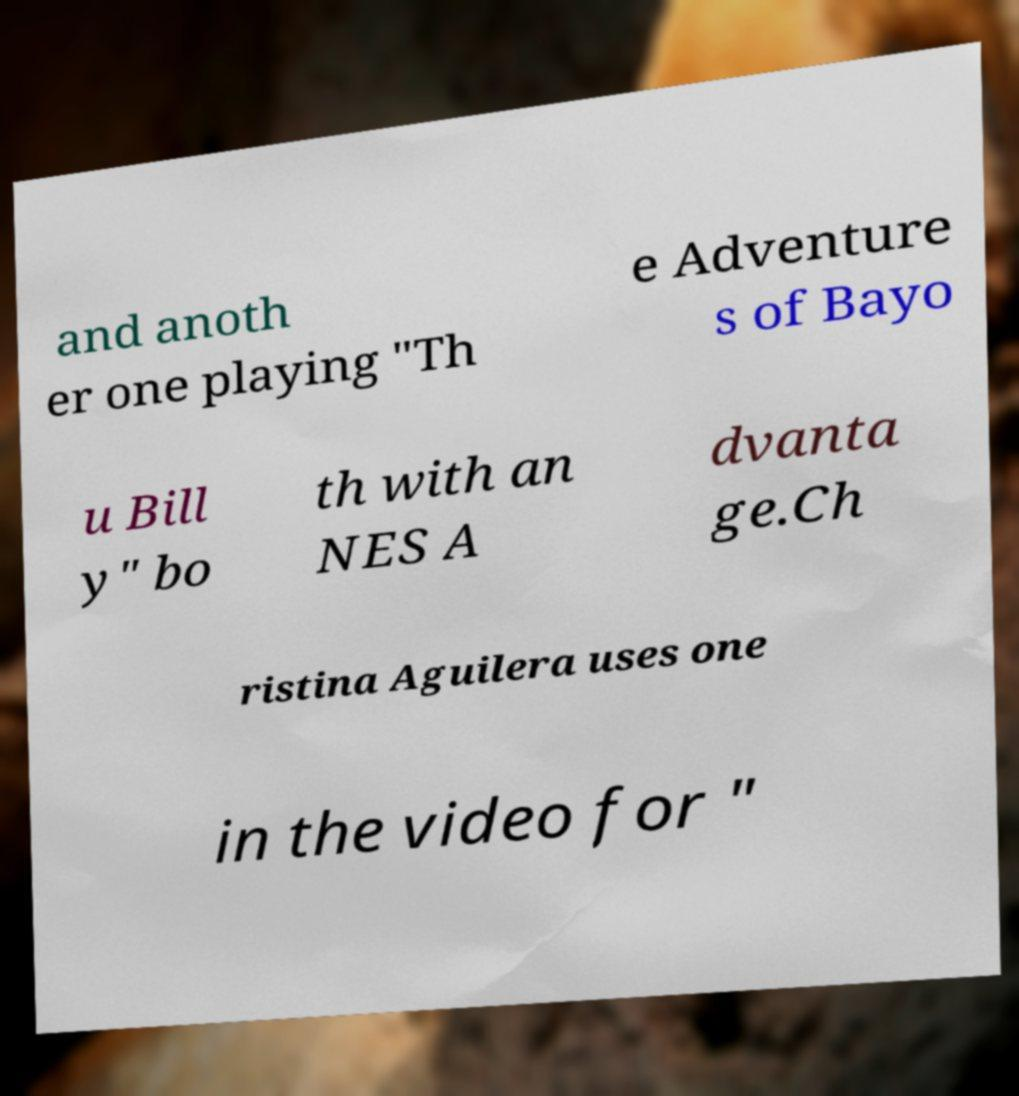What messages or text are displayed in this image? I need them in a readable, typed format. and anoth er one playing "Th e Adventure s of Bayo u Bill y" bo th with an NES A dvanta ge.Ch ristina Aguilera uses one in the video for " 